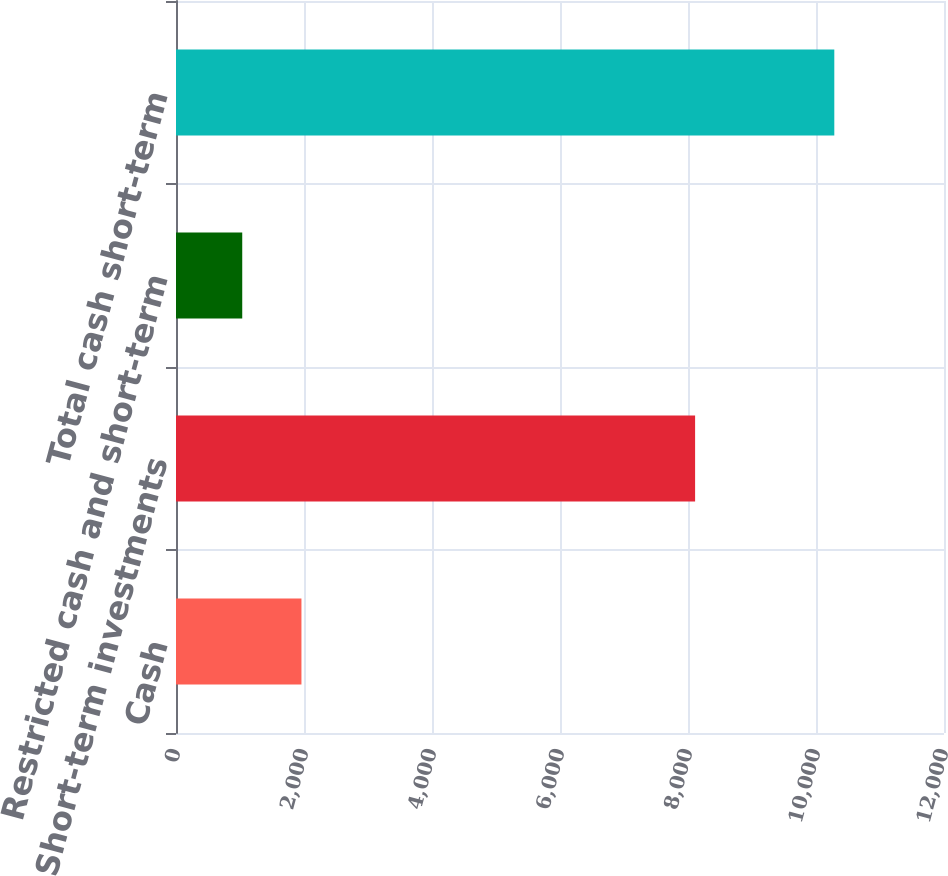Convert chart to OTSL. <chart><loc_0><loc_0><loc_500><loc_500><bar_chart><fcel>Cash<fcel>Short-term investments<fcel>Restricted cash and short-term<fcel>Total cash short-term<nl><fcel>1960.1<fcel>8111<fcel>1035<fcel>10286<nl></chart> 